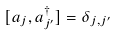Convert formula to latex. <formula><loc_0><loc_0><loc_500><loc_500>[ a _ { j } , a ^ { \dag } _ { j ^ { \prime } } ] = \delta _ { j , j ^ { \prime } }</formula> 